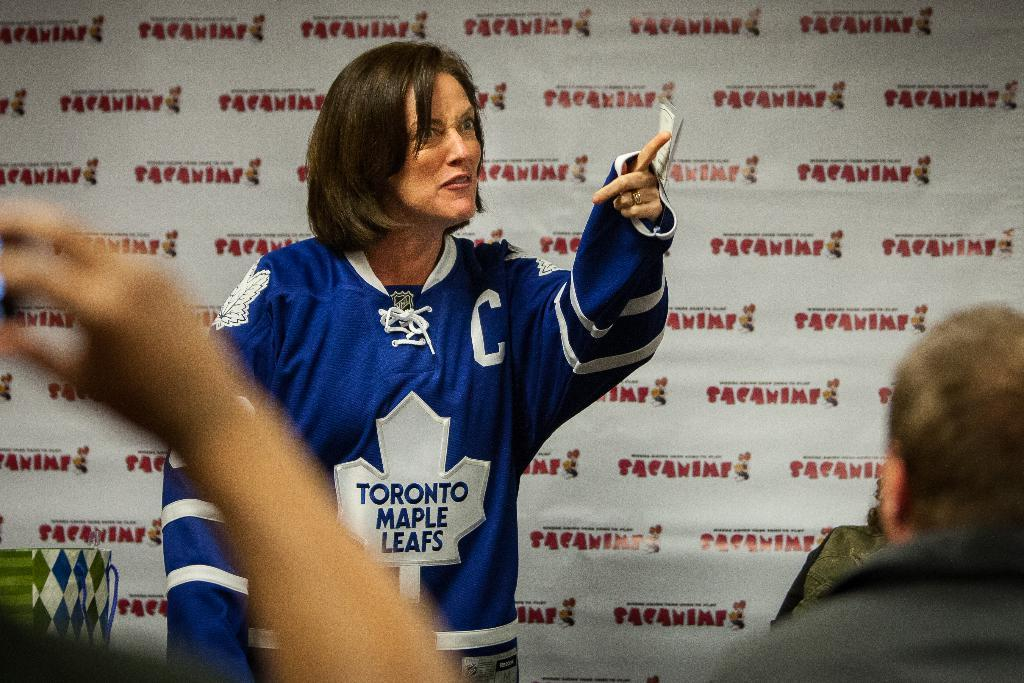<image>
Offer a succinct explanation of the picture presented. A woman wearing a Toronto Maple Leafs jersey stands and points into an audience. 